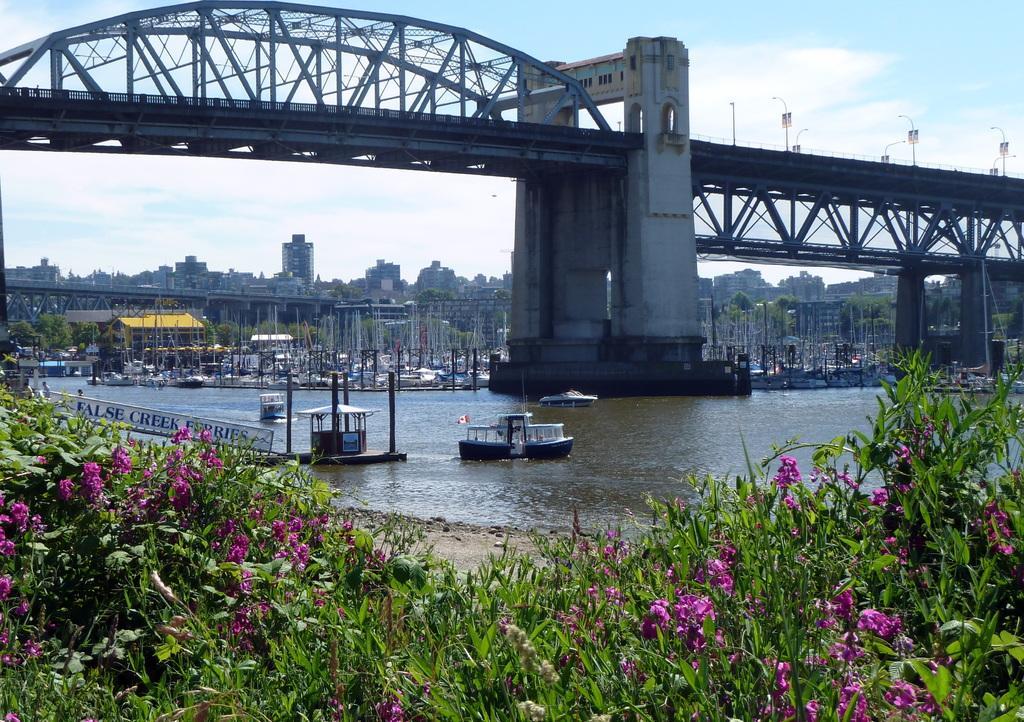Please provide a concise description of this image. In the foreground I can see flowering plants, boats in the water. In the background I can see a bridge, boats, buildings, trees and houses. On the top I can see the sky. This image is taken during a day. 